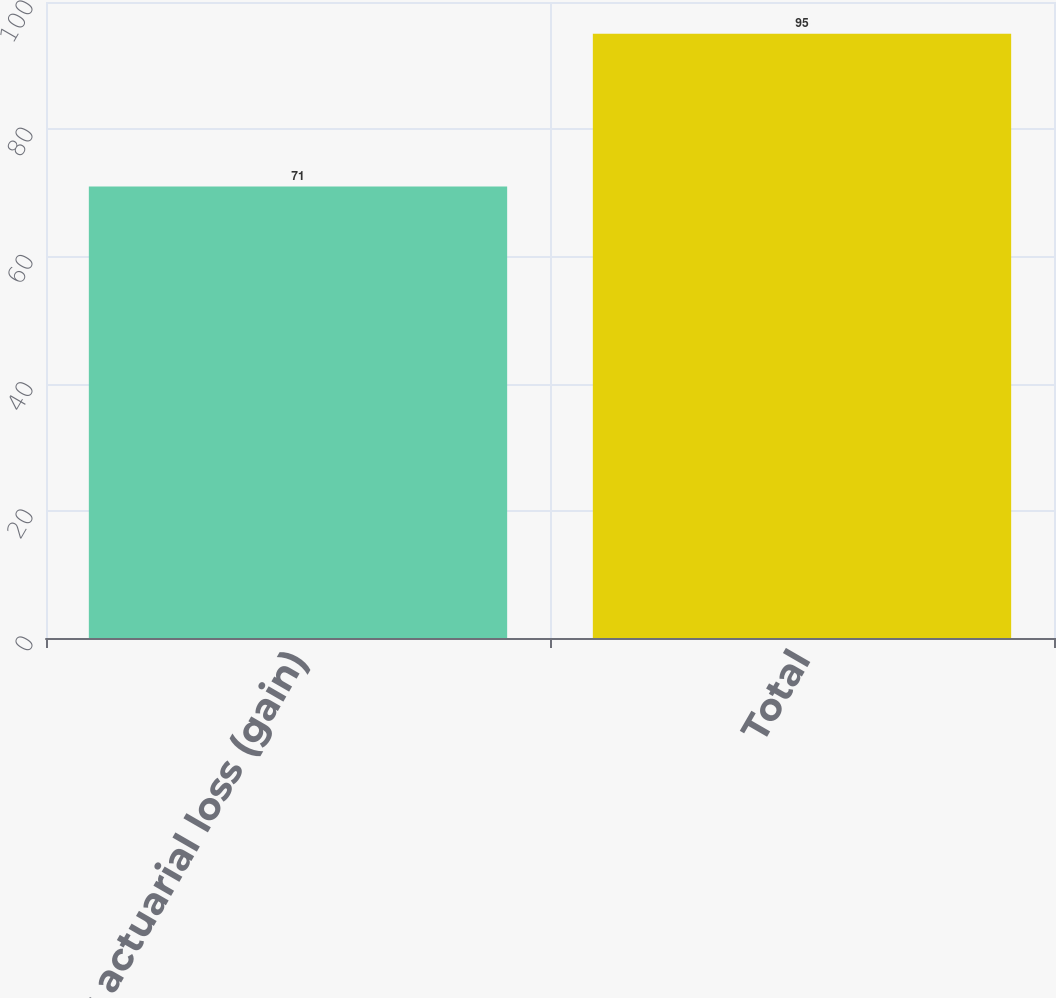Convert chart. <chart><loc_0><loc_0><loc_500><loc_500><bar_chart><fcel>Net actuarial loss (gain)<fcel>Total<nl><fcel>71<fcel>95<nl></chart> 